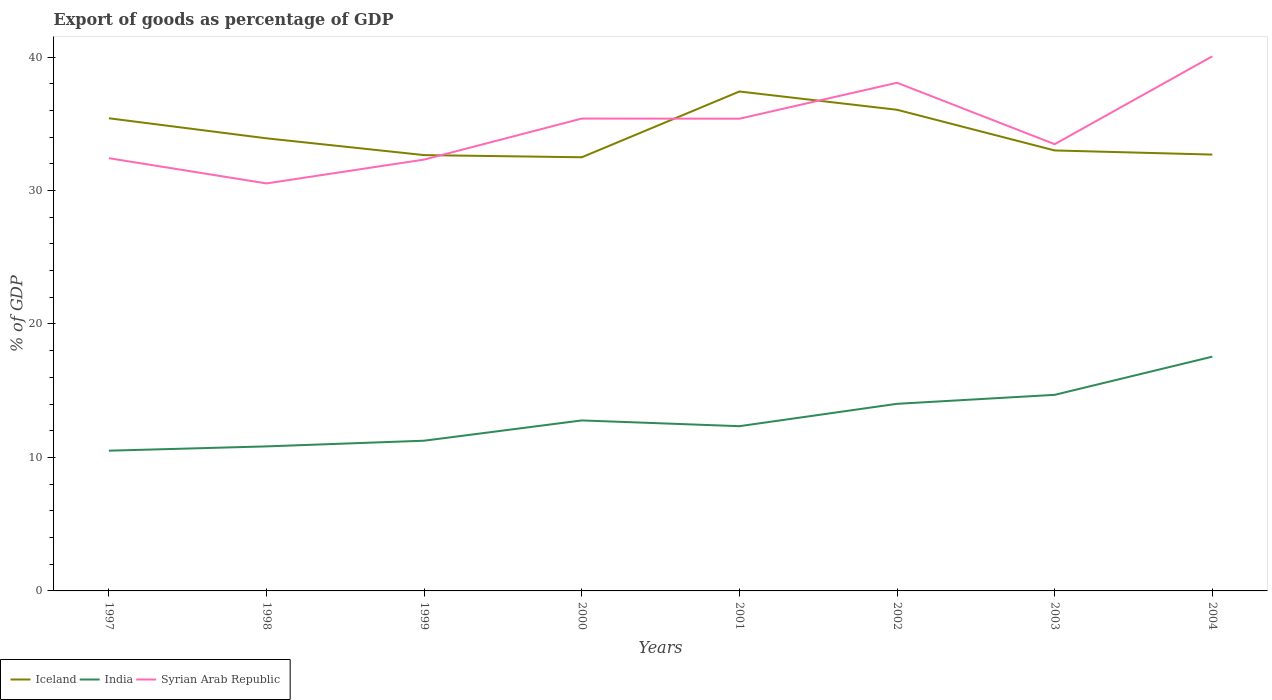Does the line corresponding to India intersect with the line corresponding to Syrian Arab Republic?
Offer a very short reply. No. Across all years, what is the maximum export of goods as percentage of GDP in Syrian Arab Republic?
Offer a terse response. 30.53. In which year was the export of goods as percentage of GDP in Iceland maximum?
Make the answer very short. 2000. What is the total export of goods as percentage of GDP in India in the graph?
Offer a terse response. -3.19. What is the difference between the highest and the second highest export of goods as percentage of GDP in Syrian Arab Republic?
Offer a terse response. 9.53. Is the export of goods as percentage of GDP in Syrian Arab Republic strictly greater than the export of goods as percentage of GDP in India over the years?
Your response must be concise. No. Does the graph contain any zero values?
Offer a terse response. No. Does the graph contain grids?
Your answer should be very brief. No. Where does the legend appear in the graph?
Make the answer very short. Bottom left. How are the legend labels stacked?
Provide a succinct answer. Horizontal. What is the title of the graph?
Your answer should be compact. Export of goods as percentage of GDP. Does "Iraq" appear as one of the legend labels in the graph?
Offer a terse response. No. What is the label or title of the X-axis?
Your response must be concise. Years. What is the label or title of the Y-axis?
Provide a succinct answer. % of GDP. What is the % of GDP of Iceland in 1997?
Provide a succinct answer. 35.41. What is the % of GDP in India in 1997?
Offer a terse response. 10.51. What is the % of GDP of Syrian Arab Republic in 1997?
Ensure brevity in your answer.  32.42. What is the % of GDP of Iceland in 1998?
Your response must be concise. 33.91. What is the % of GDP of India in 1998?
Your response must be concise. 10.83. What is the % of GDP in Syrian Arab Republic in 1998?
Offer a very short reply. 30.53. What is the % of GDP of Iceland in 1999?
Keep it short and to the point. 32.65. What is the % of GDP in India in 1999?
Make the answer very short. 11.25. What is the % of GDP in Syrian Arab Republic in 1999?
Ensure brevity in your answer.  32.32. What is the % of GDP of Iceland in 2000?
Your response must be concise. 32.49. What is the % of GDP of India in 2000?
Offer a very short reply. 12.77. What is the % of GDP in Syrian Arab Republic in 2000?
Make the answer very short. 35.39. What is the % of GDP in Iceland in 2001?
Your response must be concise. 37.42. What is the % of GDP in India in 2001?
Provide a succinct answer. 12.34. What is the % of GDP of Syrian Arab Republic in 2001?
Your answer should be very brief. 35.38. What is the % of GDP of Iceland in 2002?
Provide a succinct answer. 36.05. What is the % of GDP in India in 2002?
Your answer should be compact. 14.02. What is the % of GDP in Syrian Arab Republic in 2002?
Your answer should be compact. 38.07. What is the % of GDP of Iceland in 2003?
Keep it short and to the point. 33. What is the % of GDP of India in 2003?
Give a very brief answer. 14.69. What is the % of GDP of Syrian Arab Republic in 2003?
Make the answer very short. 33.47. What is the % of GDP in Iceland in 2004?
Your answer should be very brief. 32.69. What is the % of GDP in India in 2004?
Your response must be concise. 17.55. What is the % of GDP in Syrian Arab Republic in 2004?
Give a very brief answer. 40.05. Across all years, what is the maximum % of GDP of Iceland?
Ensure brevity in your answer.  37.42. Across all years, what is the maximum % of GDP in India?
Offer a very short reply. 17.55. Across all years, what is the maximum % of GDP in Syrian Arab Republic?
Provide a succinct answer. 40.05. Across all years, what is the minimum % of GDP of Iceland?
Your response must be concise. 32.49. Across all years, what is the minimum % of GDP in India?
Ensure brevity in your answer.  10.51. Across all years, what is the minimum % of GDP of Syrian Arab Republic?
Your answer should be compact. 30.53. What is the total % of GDP of Iceland in the graph?
Ensure brevity in your answer.  273.62. What is the total % of GDP in India in the graph?
Keep it short and to the point. 103.97. What is the total % of GDP of Syrian Arab Republic in the graph?
Make the answer very short. 277.63. What is the difference between the % of GDP in Iceland in 1997 and that in 1998?
Provide a short and direct response. 1.5. What is the difference between the % of GDP in India in 1997 and that in 1998?
Make the answer very short. -0.32. What is the difference between the % of GDP in Syrian Arab Republic in 1997 and that in 1998?
Make the answer very short. 1.89. What is the difference between the % of GDP in Iceland in 1997 and that in 1999?
Ensure brevity in your answer.  2.76. What is the difference between the % of GDP in India in 1997 and that in 1999?
Provide a succinct answer. -0.75. What is the difference between the % of GDP of Syrian Arab Republic in 1997 and that in 1999?
Your answer should be compact. 0.1. What is the difference between the % of GDP of Iceland in 1997 and that in 2000?
Your response must be concise. 2.92. What is the difference between the % of GDP in India in 1997 and that in 2000?
Provide a short and direct response. -2.27. What is the difference between the % of GDP in Syrian Arab Republic in 1997 and that in 2000?
Your answer should be very brief. -2.97. What is the difference between the % of GDP of Iceland in 1997 and that in 2001?
Provide a succinct answer. -2.01. What is the difference between the % of GDP in India in 1997 and that in 2001?
Ensure brevity in your answer.  -1.84. What is the difference between the % of GDP in Syrian Arab Republic in 1997 and that in 2001?
Provide a short and direct response. -2.96. What is the difference between the % of GDP in Iceland in 1997 and that in 2002?
Your response must be concise. -0.64. What is the difference between the % of GDP of India in 1997 and that in 2002?
Keep it short and to the point. -3.51. What is the difference between the % of GDP in Syrian Arab Republic in 1997 and that in 2002?
Offer a terse response. -5.65. What is the difference between the % of GDP in Iceland in 1997 and that in 2003?
Your answer should be very brief. 2.41. What is the difference between the % of GDP of India in 1997 and that in 2003?
Your answer should be compact. -4.18. What is the difference between the % of GDP in Syrian Arab Republic in 1997 and that in 2003?
Offer a very short reply. -1.05. What is the difference between the % of GDP of Iceland in 1997 and that in 2004?
Ensure brevity in your answer.  2.72. What is the difference between the % of GDP in India in 1997 and that in 2004?
Give a very brief answer. -7.04. What is the difference between the % of GDP of Syrian Arab Republic in 1997 and that in 2004?
Provide a short and direct response. -7.63. What is the difference between the % of GDP in Iceland in 1998 and that in 1999?
Keep it short and to the point. 1.26. What is the difference between the % of GDP of India in 1998 and that in 1999?
Provide a succinct answer. -0.43. What is the difference between the % of GDP of Syrian Arab Republic in 1998 and that in 1999?
Provide a short and direct response. -1.79. What is the difference between the % of GDP in Iceland in 1998 and that in 2000?
Provide a short and direct response. 1.42. What is the difference between the % of GDP of India in 1998 and that in 2000?
Offer a very short reply. -1.94. What is the difference between the % of GDP of Syrian Arab Republic in 1998 and that in 2000?
Ensure brevity in your answer.  -4.86. What is the difference between the % of GDP of Iceland in 1998 and that in 2001?
Provide a succinct answer. -3.51. What is the difference between the % of GDP in India in 1998 and that in 2001?
Give a very brief answer. -1.51. What is the difference between the % of GDP in Syrian Arab Republic in 1998 and that in 2001?
Your answer should be compact. -4.85. What is the difference between the % of GDP of Iceland in 1998 and that in 2002?
Keep it short and to the point. -2.14. What is the difference between the % of GDP in India in 1998 and that in 2002?
Your answer should be compact. -3.19. What is the difference between the % of GDP in Syrian Arab Republic in 1998 and that in 2002?
Your response must be concise. -7.54. What is the difference between the % of GDP in Iceland in 1998 and that in 2003?
Your answer should be compact. 0.91. What is the difference between the % of GDP in India in 1998 and that in 2003?
Ensure brevity in your answer.  -3.86. What is the difference between the % of GDP in Syrian Arab Republic in 1998 and that in 2003?
Your response must be concise. -2.94. What is the difference between the % of GDP in Iceland in 1998 and that in 2004?
Offer a very short reply. 1.22. What is the difference between the % of GDP in India in 1998 and that in 2004?
Provide a succinct answer. -6.72. What is the difference between the % of GDP of Syrian Arab Republic in 1998 and that in 2004?
Offer a very short reply. -9.53. What is the difference between the % of GDP of Iceland in 1999 and that in 2000?
Provide a succinct answer. 0.16. What is the difference between the % of GDP of India in 1999 and that in 2000?
Your response must be concise. -1.52. What is the difference between the % of GDP in Syrian Arab Republic in 1999 and that in 2000?
Provide a short and direct response. -3.07. What is the difference between the % of GDP of Iceland in 1999 and that in 2001?
Provide a succinct answer. -4.77. What is the difference between the % of GDP in India in 1999 and that in 2001?
Make the answer very short. -1.09. What is the difference between the % of GDP of Syrian Arab Republic in 1999 and that in 2001?
Offer a terse response. -3.06. What is the difference between the % of GDP of Iceland in 1999 and that in 2002?
Ensure brevity in your answer.  -3.4. What is the difference between the % of GDP of India in 1999 and that in 2002?
Offer a terse response. -2.76. What is the difference between the % of GDP of Syrian Arab Republic in 1999 and that in 2002?
Give a very brief answer. -5.76. What is the difference between the % of GDP in Iceland in 1999 and that in 2003?
Offer a terse response. -0.35. What is the difference between the % of GDP in India in 1999 and that in 2003?
Give a very brief answer. -3.44. What is the difference between the % of GDP of Syrian Arab Republic in 1999 and that in 2003?
Your answer should be compact. -1.15. What is the difference between the % of GDP of Iceland in 1999 and that in 2004?
Your response must be concise. -0.04. What is the difference between the % of GDP of India in 1999 and that in 2004?
Your response must be concise. -6.3. What is the difference between the % of GDP of Syrian Arab Republic in 1999 and that in 2004?
Provide a short and direct response. -7.74. What is the difference between the % of GDP of Iceland in 2000 and that in 2001?
Give a very brief answer. -4.93. What is the difference between the % of GDP in India in 2000 and that in 2001?
Offer a terse response. 0.43. What is the difference between the % of GDP in Syrian Arab Republic in 2000 and that in 2001?
Make the answer very short. 0.01. What is the difference between the % of GDP of Iceland in 2000 and that in 2002?
Keep it short and to the point. -3.56. What is the difference between the % of GDP of India in 2000 and that in 2002?
Provide a succinct answer. -1.25. What is the difference between the % of GDP of Syrian Arab Republic in 2000 and that in 2002?
Provide a short and direct response. -2.68. What is the difference between the % of GDP of Iceland in 2000 and that in 2003?
Give a very brief answer. -0.51. What is the difference between the % of GDP of India in 2000 and that in 2003?
Provide a succinct answer. -1.92. What is the difference between the % of GDP of Syrian Arab Republic in 2000 and that in 2003?
Make the answer very short. 1.92. What is the difference between the % of GDP of Iceland in 2000 and that in 2004?
Your response must be concise. -0.2. What is the difference between the % of GDP of India in 2000 and that in 2004?
Your answer should be very brief. -4.78. What is the difference between the % of GDP in Syrian Arab Republic in 2000 and that in 2004?
Your response must be concise. -4.66. What is the difference between the % of GDP of Iceland in 2001 and that in 2002?
Give a very brief answer. 1.37. What is the difference between the % of GDP of India in 2001 and that in 2002?
Offer a very short reply. -1.68. What is the difference between the % of GDP of Syrian Arab Republic in 2001 and that in 2002?
Offer a very short reply. -2.69. What is the difference between the % of GDP in Iceland in 2001 and that in 2003?
Ensure brevity in your answer.  4.42. What is the difference between the % of GDP in India in 2001 and that in 2003?
Give a very brief answer. -2.35. What is the difference between the % of GDP of Syrian Arab Republic in 2001 and that in 2003?
Your answer should be very brief. 1.91. What is the difference between the % of GDP in Iceland in 2001 and that in 2004?
Offer a terse response. 4.73. What is the difference between the % of GDP of India in 2001 and that in 2004?
Give a very brief answer. -5.21. What is the difference between the % of GDP of Syrian Arab Republic in 2001 and that in 2004?
Give a very brief answer. -4.68. What is the difference between the % of GDP in Iceland in 2002 and that in 2003?
Your answer should be compact. 3.05. What is the difference between the % of GDP of India in 2002 and that in 2003?
Give a very brief answer. -0.67. What is the difference between the % of GDP of Syrian Arab Republic in 2002 and that in 2003?
Your answer should be very brief. 4.6. What is the difference between the % of GDP of Iceland in 2002 and that in 2004?
Keep it short and to the point. 3.36. What is the difference between the % of GDP of India in 2002 and that in 2004?
Your answer should be very brief. -3.53. What is the difference between the % of GDP of Syrian Arab Republic in 2002 and that in 2004?
Provide a succinct answer. -1.98. What is the difference between the % of GDP of Iceland in 2003 and that in 2004?
Your answer should be very brief. 0.31. What is the difference between the % of GDP of India in 2003 and that in 2004?
Your answer should be very brief. -2.86. What is the difference between the % of GDP in Syrian Arab Republic in 2003 and that in 2004?
Make the answer very short. -6.58. What is the difference between the % of GDP in Iceland in 1997 and the % of GDP in India in 1998?
Your response must be concise. 24.58. What is the difference between the % of GDP of Iceland in 1997 and the % of GDP of Syrian Arab Republic in 1998?
Provide a short and direct response. 4.88. What is the difference between the % of GDP of India in 1997 and the % of GDP of Syrian Arab Republic in 1998?
Your answer should be very brief. -20.02. What is the difference between the % of GDP of Iceland in 1997 and the % of GDP of India in 1999?
Your answer should be very brief. 24.16. What is the difference between the % of GDP of Iceland in 1997 and the % of GDP of Syrian Arab Republic in 1999?
Your answer should be very brief. 3.09. What is the difference between the % of GDP in India in 1997 and the % of GDP in Syrian Arab Republic in 1999?
Give a very brief answer. -21.81. What is the difference between the % of GDP in Iceland in 1997 and the % of GDP in India in 2000?
Provide a short and direct response. 22.64. What is the difference between the % of GDP of Iceland in 1997 and the % of GDP of Syrian Arab Republic in 2000?
Provide a short and direct response. 0.02. What is the difference between the % of GDP in India in 1997 and the % of GDP in Syrian Arab Republic in 2000?
Offer a very short reply. -24.88. What is the difference between the % of GDP of Iceland in 1997 and the % of GDP of India in 2001?
Your answer should be compact. 23.07. What is the difference between the % of GDP of Iceland in 1997 and the % of GDP of Syrian Arab Republic in 2001?
Give a very brief answer. 0.03. What is the difference between the % of GDP of India in 1997 and the % of GDP of Syrian Arab Republic in 2001?
Give a very brief answer. -24.87. What is the difference between the % of GDP in Iceland in 1997 and the % of GDP in India in 2002?
Offer a terse response. 21.39. What is the difference between the % of GDP of Iceland in 1997 and the % of GDP of Syrian Arab Republic in 2002?
Your response must be concise. -2.66. What is the difference between the % of GDP of India in 1997 and the % of GDP of Syrian Arab Republic in 2002?
Make the answer very short. -27.57. What is the difference between the % of GDP in Iceland in 1997 and the % of GDP in India in 2003?
Offer a terse response. 20.72. What is the difference between the % of GDP of Iceland in 1997 and the % of GDP of Syrian Arab Republic in 2003?
Provide a succinct answer. 1.94. What is the difference between the % of GDP in India in 1997 and the % of GDP in Syrian Arab Republic in 2003?
Your response must be concise. -22.96. What is the difference between the % of GDP of Iceland in 1997 and the % of GDP of India in 2004?
Make the answer very short. 17.86. What is the difference between the % of GDP of Iceland in 1997 and the % of GDP of Syrian Arab Republic in 2004?
Ensure brevity in your answer.  -4.64. What is the difference between the % of GDP in India in 1997 and the % of GDP in Syrian Arab Republic in 2004?
Give a very brief answer. -29.55. What is the difference between the % of GDP in Iceland in 1998 and the % of GDP in India in 1999?
Keep it short and to the point. 22.65. What is the difference between the % of GDP in Iceland in 1998 and the % of GDP in Syrian Arab Republic in 1999?
Make the answer very short. 1.59. What is the difference between the % of GDP in India in 1998 and the % of GDP in Syrian Arab Republic in 1999?
Offer a very short reply. -21.49. What is the difference between the % of GDP of Iceland in 1998 and the % of GDP of India in 2000?
Your answer should be very brief. 21.14. What is the difference between the % of GDP in Iceland in 1998 and the % of GDP in Syrian Arab Republic in 2000?
Keep it short and to the point. -1.48. What is the difference between the % of GDP of India in 1998 and the % of GDP of Syrian Arab Republic in 2000?
Your answer should be very brief. -24.56. What is the difference between the % of GDP in Iceland in 1998 and the % of GDP in India in 2001?
Keep it short and to the point. 21.57. What is the difference between the % of GDP of Iceland in 1998 and the % of GDP of Syrian Arab Republic in 2001?
Provide a short and direct response. -1.47. What is the difference between the % of GDP of India in 1998 and the % of GDP of Syrian Arab Republic in 2001?
Your answer should be very brief. -24.55. What is the difference between the % of GDP in Iceland in 1998 and the % of GDP in India in 2002?
Make the answer very short. 19.89. What is the difference between the % of GDP of Iceland in 1998 and the % of GDP of Syrian Arab Republic in 2002?
Offer a terse response. -4.16. What is the difference between the % of GDP of India in 1998 and the % of GDP of Syrian Arab Republic in 2002?
Provide a short and direct response. -27.24. What is the difference between the % of GDP in Iceland in 1998 and the % of GDP in India in 2003?
Your response must be concise. 19.22. What is the difference between the % of GDP of Iceland in 1998 and the % of GDP of Syrian Arab Republic in 2003?
Provide a succinct answer. 0.44. What is the difference between the % of GDP in India in 1998 and the % of GDP in Syrian Arab Republic in 2003?
Keep it short and to the point. -22.64. What is the difference between the % of GDP of Iceland in 1998 and the % of GDP of India in 2004?
Offer a terse response. 16.36. What is the difference between the % of GDP in Iceland in 1998 and the % of GDP in Syrian Arab Republic in 2004?
Your answer should be very brief. -6.15. What is the difference between the % of GDP of India in 1998 and the % of GDP of Syrian Arab Republic in 2004?
Your response must be concise. -29.23. What is the difference between the % of GDP of Iceland in 1999 and the % of GDP of India in 2000?
Offer a very short reply. 19.88. What is the difference between the % of GDP in Iceland in 1999 and the % of GDP in Syrian Arab Republic in 2000?
Your answer should be compact. -2.74. What is the difference between the % of GDP of India in 1999 and the % of GDP of Syrian Arab Republic in 2000?
Offer a terse response. -24.13. What is the difference between the % of GDP of Iceland in 1999 and the % of GDP of India in 2001?
Your answer should be very brief. 20.31. What is the difference between the % of GDP in Iceland in 1999 and the % of GDP in Syrian Arab Republic in 2001?
Your answer should be very brief. -2.73. What is the difference between the % of GDP of India in 1999 and the % of GDP of Syrian Arab Republic in 2001?
Give a very brief answer. -24.12. What is the difference between the % of GDP of Iceland in 1999 and the % of GDP of India in 2002?
Keep it short and to the point. 18.63. What is the difference between the % of GDP of Iceland in 1999 and the % of GDP of Syrian Arab Republic in 2002?
Provide a succinct answer. -5.42. What is the difference between the % of GDP of India in 1999 and the % of GDP of Syrian Arab Republic in 2002?
Offer a very short reply. -26.82. What is the difference between the % of GDP of Iceland in 1999 and the % of GDP of India in 2003?
Offer a very short reply. 17.96. What is the difference between the % of GDP of Iceland in 1999 and the % of GDP of Syrian Arab Republic in 2003?
Provide a short and direct response. -0.82. What is the difference between the % of GDP of India in 1999 and the % of GDP of Syrian Arab Republic in 2003?
Keep it short and to the point. -22.22. What is the difference between the % of GDP in Iceland in 1999 and the % of GDP in India in 2004?
Your response must be concise. 15.1. What is the difference between the % of GDP in Iceland in 1999 and the % of GDP in Syrian Arab Republic in 2004?
Provide a short and direct response. -7.4. What is the difference between the % of GDP in India in 1999 and the % of GDP in Syrian Arab Republic in 2004?
Your answer should be compact. -28.8. What is the difference between the % of GDP in Iceland in 2000 and the % of GDP in India in 2001?
Offer a terse response. 20.15. What is the difference between the % of GDP in Iceland in 2000 and the % of GDP in Syrian Arab Republic in 2001?
Your response must be concise. -2.89. What is the difference between the % of GDP in India in 2000 and the % of GDP in Syrian Arab Republic in 2001?
Keep it short and to the point. -22.61. What is the difference between the % of GDP in Iceland in 2000 and the % of GDP in India in 2002?
Ensure brevity in your answer.  18.47. What is the difference between the % of GDP in Iceland in 2000 and the % of GDP in Syrian Arab Republic in 2002?
Your response must be concise. -5.58. What is the difference between the % of GDP of India in 2000 and the % of GDP of Syrian Arab Republic in 2002?
Provide a succinct answer. -25.3. What is the difference between the % of GDP of Iceland in 2000 and the % of GDP of India in 2003?
Your response must be concise. 17.8. What is the difference between the % of GDP in Iceland in 2000 and the % of GDP in Syrian Arab Republic in 2003?
Provide a short and direct response. -0.98. What is the difference between the % of GDP in India in 2000 and the % of GDP in Syrian Arab Republic in 2003?
Make the answer very short. -20.7. What is the difference between the % of GDP of Iceland in 2000 and the % of GDP of India in 2004?
Provide a short and direct response. 14.94. What is the difference between the % of GDP in Iceland in 2000 and the % of GDP in Syrian Arab Republic in 2004?
Ensure brevity in your answer.  -7.57. What is the difference between the % of GDP in India in 2000 and the % of GDP in Syrian Arab Republic in 2004?
Your answer should be compact. -27.28. What is the difference between the % of GDP of Iceland in 2001 and the % of GDP of India in 2002?
Your response must be concise. 23.4. What is the difference between the % of GDP in Iceland in 2001 and the % of GDP in Syrian Arab Republic in 2002?
Make the answer very short. -0.65. What is the difference between the % of GDP of India in 2001 and the % of GDP of Syrian Arab Republic in 2002?
Make the answer very short. -25.73. What is the difference between the % of GDP in Iceland in 2001 and the % of GDP in India in 2003?
Keep it short and to the point. 22.73. What is the difference between the % of GDP of Iceland in 2001 and the % of GDP of Syrian Arab Republic in 2003?
Ensure brevity in your answer.  3.95. What is the difference between the % of GDP in India in 2001 and the % of GDP in Syrian Arab Republic in 2003?
Offer a very short reply. -21.13. What is the difference between the % of GDP of Iceland in 2001 and the % of GDP of India in 2004?
Your answer should be compact. 19.87. What is the difference between the % of GDP of Iceland in 2001 and the % of GDP of Syrian Arab Republic in 2004?
Your answer should be very brief. -2.64. What is the difference between the % of GDP of India in 2001 and the % of GDP of Syrian Arab Republic in 2004?
Give a very brief answer. -27.71. What is the difference between the % of GDP of Iceland in 2002 and the % of GDP of India in 2003?
Offer a terse response. 21.36. What is the difference between the % of GDP in Iceland in 2002 and the % of GDP in Syrian Arab Republic in 2003?
Provide a short and direct response. 2.58. What is the difference between the % of GDP of India in 2002 and the % of GDP of Syrian Arab Republic in 2003?
Provide a succinct answer. -19.45. What is the difference between the % of GDP of Iceland in 2002 and the % of GDP of India in 2004?
Provide a short and direct response. 18.5. What is the difference between the % of GDP in Iceland in 2002 and the % of GDP in Syrian Arab Republic in 2004?
Keep it short and to the point. -4.01. What is the difference between the % of GDP of India in 2002 and the % of GDP of Syrian Arab Republic in 2004?
Keep it short and to the point. -26.04. What is the difference between the % of GDP in Iceland in 2003 and the % of GDP in India in 2004?
Provide a succinct answer. 15.45. What is the difference between the % of GDP in Iceland in 2003 and the % of GDP in Syrian Arab Republic in 2004?
Ensure brevity in your answer.  -7.05. What is the difference between the % of GDP of India in 2003 and the % of GDP of Syrian Arab Republic in 2004?
Offer a terse response. -25.36. What is the average % of GDP in Iceland per year?
Your answer should be compact. 34.2. What is the average % of GDP of India per year?
Give a very brief answer. 13. What is the average % of GDP of Syrian Arab Republic per year?
Give a very brief answer. 34.7. In the year 1997, what is the difference between the % of GDP of Iceland and % of GDP of India?
Provide a short and direct response. 24.9. In the year 1997, what is the difference between the % of GDP of Iceland and % of GDP of Syrian Arab Republic?
Give a very brief answer. 2.99. In the year 1997, what is the difference between the % of GDP in India and % of GDP in Syrian Arab Republic?
Offer a very short reply. -21.91. In the year 1998, what is the difference between the % of GDP in Iceland and % of GDP in India?
Offer a terse response. 23.08. In the year 1998, what is the difference between the % of GDP in Iceland and % of GDP in Syrian Arab Republic?
Offer a terse response. 3.38. In the year 1998, what is the difference between the % of GDP of India and % of GDP of Syrian Arab Republic?
Provide a succinct answer. -19.7. In the year 1999, what is the difference between the % of GDP of Iceland and % of GDP of India?
Provide a succinct answer. 21.4. In the year 1999, what is the difference between the % of GDP in Iceland and % of GDP in Syrian Arab Republic?
Keep it short and to the point. 0.33. In the year 1999, what is the difference between the % of GDP in India and % of GDP in Syrian Arab Republic?
Provide a succinct answer. -21.06. In the year 2000, what is the difference between the % of GDP in Iceland and % of GDP in India?
Give a very brief answer. 19.72. In the year 2000, what is the difference between the % of GDP in Iceland and % of GDP in Syrian Arab Republic?
Provide a short and direct response. -2.9. In the year 2000, what is the difference between the % of GDP in India and % of GDP in Syrian Arab Republic?
Provide a succinct answer. -22.62. In the year 2001, what is the difference between the % of GDP in Iceland and % of GDP in India?
Provide a short and direct response. 25.08. In the year 2001, what is the difference between the % of GDP of Iceland and % of GDP of Syrian Arab Republic?
Ensure brevity in your answer.  2.04. In the year 2001, what is the difference between the % of GDP of India and % of GDP of Syrian Arab Republic?
Offer a terse response. -23.04. In the year 2002, what is the difference between the % of GDP in Iceland and % of GDP in India?
Keep it short and to the point. 22.03. In the year 2002, what is the difference between the % of GDP in Iceland and % of GDP in Syrian Arab Republic?
Offer a terse response. -2.02. In the year 2002, what is the difference between the % of GDP of India and % of GDP of Syrian Arab Republic?
Your answer should be compact. -24.05. In the year 2003, what is the difference between the % of GDP of Iceland and % of GDP of India?
Ensure brevity in your answer.  18.31. In the year 2003, what is the difference between the % of GDP of Iceland and % of GDP of Syrian Arab Republic?
Your answer should be compact. -0.47. In the year 2003, what is the difference between the % of GDP of India and % of GDP of Syrian Arab Republic?
Make the answer very short. -18.78. In the year 2004, what is the difference between the % of GDP of Iceland and % of GDP of India?
Ensure brevity in your answer.  15.14. In the year 2004, what is the difference between the % of GDP in Iceland and % of GDP in Syrian Arab Republic?
Ensure brevity in your answer.  -7.36. In the year 2004, what is the difference between the % of GDP of India and % of GDP of Syrian Arab Republic?
Provide a succinct answer. -22.5. What is the ratio of the % of GDP in Iceland in 1997 to that in 1998?
Your answer should be very brief. 1.04. What is the ratio of the % of GDP in India in 1997 to that in 1998?
Make the answer very short. 0.97. What is the ratio of the % of GDP in Syrian Arab Republic in 1997 to that in 1998?
Ensure brevity in your answer.  1.06. What is the ratio of the % of GDP of Iceland in 1997 to that in 1999?
Your answer should be very brief. 1.08. What is the ratio of the % of GDP in India in 1997 to that in 1999?
Keep it short and to the point. 0.93. What is the ratio of the % of GDP of Iceland in 1997 to that in 2000?
Ensure brevity in your answer.  1.09. What is the ratio of the % of GDP of India in 1997 to that in 2000?
Make the answer very short. 0.82. What is the ratio of the % of GDP of Syrian Arab Republic in 1997 to that in 2000?
Keep it short and to the point. 0.92. What is the ratio of the % of GDP of Iceland in 1997 to that in 2001?
Provide a short and direct response. 0.95. What is the ratio of the % of GDP in India in 1997 to that in 2001?
Your response must be concise. 0.85. What is the ratio of the % of GDP of Syrian Arab Republic in 1997 to that in 2001?
Offer a very short reply. 0.92. What is the ratio of the % of GDP in Iceland in 1997 to that in 2002?
Make the answer very short. 0.98. What is the ratio of the % of GDP in India in 1997 to that in 2002?
Keep it short and to the point. 0.75. What is the ratio of the % of GDP of Syrian Arab Republic in 1997 to that in 2002?
Give a very brief answer. 0.85. What is the ratio of the % of GDP in Iceland in 1997 to that in 2003?
Provide a succinct answer. 1.07. What is the ratio of the % of GDP in India in 1997 to that in 2003?
Make the answer very short. 0.72. What is the ratio of the % of GDP of Syrian Arab Republic in 1997 to that in 2003?
Provide a short and direct response. 0.97. What is the ratio of the % of GDP in Iceland in 1997 to that in 2004?
Make the answer very short. 1.08. What is the ratio of the % of GDP in India in 1997 to that in 2004?
Offer a terse response. 0.6. What is the ratio of the % of GDP in Syrian Arab Republic in 1997 to that in 2004?
Offer a terse response. 0.81. What is the ratio of the % of GDP of Iceland in 1998 to that in 1999?
Ensure brevity in your answer.  1.04. What is the ratio of the % of GDP of India in 1998 to that in 1999?
Offer a terse response. 0.96. What is the ratio of the % of GDP of Syrian Arab Republic in 1998 to that in 1999?
Keep it short and to the point. 0.94. What is the ratio of the % of GDP of Iceland in 1998 to that in 2000?
Make the answer very short. 1.04. What is the ratio of the % of GDP of India in 1998 to that in 2000?
Provide a succinct answer. 0.85. What is the ratio of the % of GDP in Syrian Arab Republic in 1998 to that in 2000?
Make the answer very short. 0.86. What is the ratio of the % of GDP of Iceland in 1998 to that in 2001?
Keep it short and to the point. 0.91. What is the ratio of the % of GDP in India in 1998 to that in 2001?
Keep it short and to the point. 0.88. What is the ratio of the % of GDP of Syrian Arab Republic in 1998 to that in 2001?
Your answer should be very brief. 0.86. What is the ratio of the % of GDP of Iceland in 1998 to that in 2002?
Provide a short and direct response. 0.94. What is the ratio of the % of GDP of India in 1998 to that in 2002?
Keep it short and to the point. 0.77. What is the ratio of the % of GDP of Syrian Arab Republic in 1998 to that in 2002?
Make the answer very short. 0.8. What is the ratio of the % of GDP in Iceland in 1998 to that in 2003?
Offer a very short reply. 1.03. What is the ratio of the % of GDP in India in 1998 to that in 2003?
Your response must be concise. 0.74. What is the ratio of the % of GDP of Syrian Arab Republic in 1998 to that in 2003?
Offer a terse response. 0.91. What is the ratio of the % of GDP of Iceland in 1998 to that in 2004?
Give a very brief answer. 1.04. What is the ratio of the % of GDP of India in 1998 to that in 2004?
Offer a very short reply. 0.62. What is the ratio of the % of GDP in Syrian Arab Republic in 1998 to that in 2004?
Your response must be concise. 0.76. What is the ratio of the % of GDP of Iceland in 1999 to that in 2000?
Give a very brief answer. 1. What is the ratio of the % of GDP of India in 1999 to that in 2000?
Offer a terse response. 0.88. What is the ratio of the % of GDP of Syrian Arab Republic in 1999 to that in 2000?
Your answer should be compact. 0.91. What is the ratio of the % of GDP in Iceland in 1999 to that in 2001?
Make the answer very short. 0.87. What is the ratio of the % of GDP in India in 1999 to that in 2001?
Provide a short and direct response. 0.91. What is the ratio of the % of GDP in Syrian Arab Republic in 1999 to that in 2001?
Offer a very short reply. 0.91. What is the ratio of the % of GDP in Iceland in 1999 to that in 2002?
Provide a succinct answer. 0.91. What is the ratio of the % of GDP in India in 1999 to that in 2002?
Offer a very short reply. 0.8. What is the ratio of the % of GDP in Syrian Arab Republic in 1999 to that in 2002?
Make the answer very short. 0.85. What is the ratio of the % of GDP in Iceland in 1999 to that in 2003?
Give a very brief answer. 0.99. What is the ratio of the % of GDP in India in 1999 to that in 2003?
Make the answer very short. 0.77. What is the ratio of the % of GDP of Syrian Arab Republic in 1999 to that in 2003?
Your answer should be very brief. 0.97. What is the ratio of the % of GDP of Iceland in 1999 to that in 2004?
Give a very brief answer. 1. What is the ratio of the % of GDP of India in 1999 to that in 2004?
Provide a short and direct response. 0.64. What is the ratio of the % of GDP in Syrian Arab Republic in 1999 to that in 2004?
Provide a succinct answer. 0.81. What is the ratio of the % of GDP of Iceland in 2000 to that in 2001?
Ensure brevity in your answer.  0.87. What is the ratio of the % of GDP of India in 2000 to that in 2001?
Your response must be concise. 1.03. What is the ratio of the % of GDP of Syrian Arab Republic in 2000 to that in 2001?
Provide a succinct answer. 1. What is the ratio of the % of GDP in Iceland in 2000 to that in 2002?
Give a very brief answer. 0.9. What is the ratio of the % of GDP in India in 2000 to that in 2002?
Keep it short and to the point. 0.91. What is the ratio of the % of GDP of Syrian Arab Republic in 2000 to that in 2002?
Offer a terse response. 0.93. What is the ratio of the % of GDP in Iceland in 2000 to that in 2003?
Ensure brevity in your answer.  0.98. What is the ratio of the % of GDP of India in 2000 to that in 2003?
Your answer should be very brief. 0.87. What is the ratio of the % of GDP in Syrian Arab Republic in 2000 to that in 2003?
Make the answer very short. 1.06. What is the ratio of the % of GDP of Iceland in 2000 to that in 2004?
Keep it short and to the point. 0.99. What is the ratio of the % of GDP of India in 2000 to that in 2004?
Provide a succinct answer. 0.73. What is the ratio of the % of GDP in Syrian Arab Republic in 2000 to that in 2004?
Your response must be concise. 0.88. What is the ratio of the % of GDP of Iceland in 2001 to that in 2002?
Provide a succinct answer. 1.04. What is the ratio of the % of GDP in India in 2001 to that in 2002?
Offer a very short reply. 0.88. What is the ratio of the % of GDP in Syrian Arab Republic in 2001 to that in 2002?
Provide a succinct answer. 0.93. What is the ratio of the % of GDP of Iceland in 2001 to that in 2003?
Offer a very short reply. 1.13. What is the ratio of the % of GDP in India in 2001 to that in 2003?
Keep it short and to the point. 0.84. What is the ratio of the % of GDP of Syrian Arab Republic in 2001 to that in 2003?
Ensure brevity in your answer.  1.06. What is the ratio of the % of GDP in Iceland in 2001 to that in 2004?
Your answer should be very brief. 1.14. What is the ratio of the % of GDP in India in 2001 to that in 2004?
Your response must be concise. 0.7. What is the ratio of the % of GDP of Syrian Arab Republic in 2001 to that in 2004?
Your answer should be very brief. 0.88. What is the ratio of the % of GDP of Iceland in 2002 to that in 2003?
Give a very brief answer. 1.09. What is the ratio of the % of GDP of India in 2002 to that in 2003?
Keep it short and to the point. 0.95. What is the ratio of the % of GDP in Syrian Arab Republic in 2002 to that in 2003?
Give a very brief answer. 1.14. What is the ratio of the % of GDP of Iceland in 2002 to that in 2004?
Give a very brief answer. 1.1. What is the ratio of the % of GDP of India in 2002 to that in 2004?
Your response must be concise. 0.8. What is the ratio of the % of GDP of Syrian Arab Republic in 2002 to that in 2004?
Keep it short and to the point. 0.95. What is the ratio of the % of GDP of Iceland in 2003 to that in 2004?
Provide a succinct answer. 1.01. What is the ratio of the % of GDP in India in 2003 to that in 2004?
Ensure brevity in your answer.  0.84. What is the ratio of the % of GDP of Syrian Arab Republic in 2003 to that in 2004?
Provide a short and direct response. 0.84. What is the difference between the highest and the second highest % of GDP in Iceland?
Make the answer very short. 1.37. What is the difference between the highest and the second highest % of GDP of India?
Provide a succinct answer. 2.86. What is the difference between the highest and the second highest % of GDP in Syrian Arab Republic?
Provide a short and direct response. 1.98. What is the difference between the highest and the lowest % of GDP in Iceland?
Give a very brief answer. 4.93. What is the difference between the highest and the lowest % of GDP of India?
Your answer should be compact. 7.04. What is the difference between the highest and the lowest % of GDP in Syrian Arab Republic?
Offer a very short reply. 9.53. 